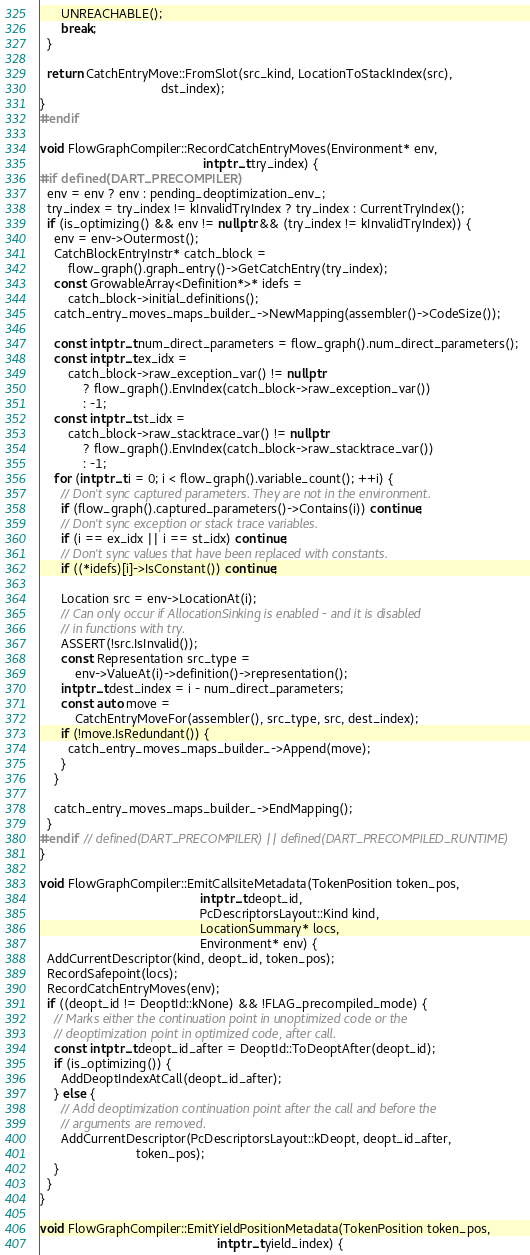Convert code to text. <code><loc_0><loc_0><loc_500><loc_500><_C++_>      UNREACHABLE();
      break;
  }

  return CatchEntryMove::FromSlot(src_kind, LocationToStackIndex(src),
                                  dst_index);
}
#endif

void FlowGraphCompiler::RecordCatchEntryMoves(Environment* env,
                                              intptr_t try_index) {
#if defined(DART_PRECOMPILER)
  env = env ? env : pending_deoptimization_env_;
  try_index = try_index != kInvalidTryIndex ? try_index : CurrentTryIndex();
  if (is_optimizing() && env != nullptr && (try_index != kInvalidTryIndex)) {
    env = env->Outermost();
    CatchBlockEntryInstr* catch_block =
        flow_graph().graph_entry()->GetCatchEntry(try_index);
    const GrowableArray<Definition*>* idefs =
        catch_block->initial_definitions();
    catch_entry_moves_maps_builder_->NewMapping(assembler()->CodeSize());

    const intptr_t num_direct_parameters = flow_graph().num_direct_parameters();
    const intptr_t ex_idx =
        catch_block->raw_exception_var() != nullptr
            ? flow_graph().EnvIndex(catch_block->raw_exception_var())
            : -1;
    const intptr_t st_idx =
        catch_block->raw_stacktrace_var() != nullptr
            ? flow_graph().EnvIndex(catch_block->raw_stacktrace_var())
            : -1;
    for (intptr_t i = 0; i < flow_graph().variable_count(); ++i) {
      // Don't sync captured parameters. They are not in the environment.
      if (flow_graph().captured_parameters()->Contains(i)) continue;
      // Don't sync exception or stack trace variables.
      if (i == ex_idx || i == st_idx) continue;
      // Don't sync values that have been replaced with constants.
      if ((*idefs)[i]->IsConstant()) continue;

      Location src = env->LocationAt(i);
      // Can only occur if AllocationSinking is enabled - and it is disabled
      // in functions with try.
      ASSERT(!src.IsInvalid());
      const Representation src_type =
          env->ValueAt(i)->definition()->representation();
      intptr_t dest_index = i - num_direct_parameters;
      const auto move =
          CatchEntryMoveFor(assembler(), src_type, src, dest_index);
      if (!move.IsRedundant()) {
        catch_entry_moves_maps_builder_->Append(move);
      }
    }

    catch_entry_moves_maps_builder_->EndMapping();
  }
#endif  // defined(DART_PRECOMPILER) || defined(DART_PRECOMPILED_RUNTIME)
}

void FlowGraphCompiler::EmitCallsiteMetadata(TokenPosition token_pos,
                                             intptr_t deopt_id,
                                             PcDescriptorsLayout::Kind kind,
                                             LocationSummary* locs,
                                             Environment* env) {
  AddCurrentDescriptor(kind, deopt_id, token_pos);
  RecordSafepoint(locs);
  RecordCatchEntryMoves(env);
  if ((deopt_id != DeoptId::kNone) && !FLAG_precompiled_mode) {
    // Marks either the continuation point in unoptimized code or the
    // deoptimization point in optimized code, after call.
    const intptr_t deopt_id_after = DeoptId::ToDeoptAfter(deopt_id);
    if (is_optimizing()) {
      AddDeoptIndexAtCall(deopt_id_after);
    } else {
      // Add deoptimization continuation point after the call and before the
      // arguments are removed.
      AddCurrentDescriptor(PcDescriptorsLayout::kDeopt, deopt_id_after,
                           token_pos);
    }
  }
}

void FlowGraphCompiler::EmitYieldPositionMetadata(TokenPosition token_pos,
                                                  intptr_t yield_index) {</code> 